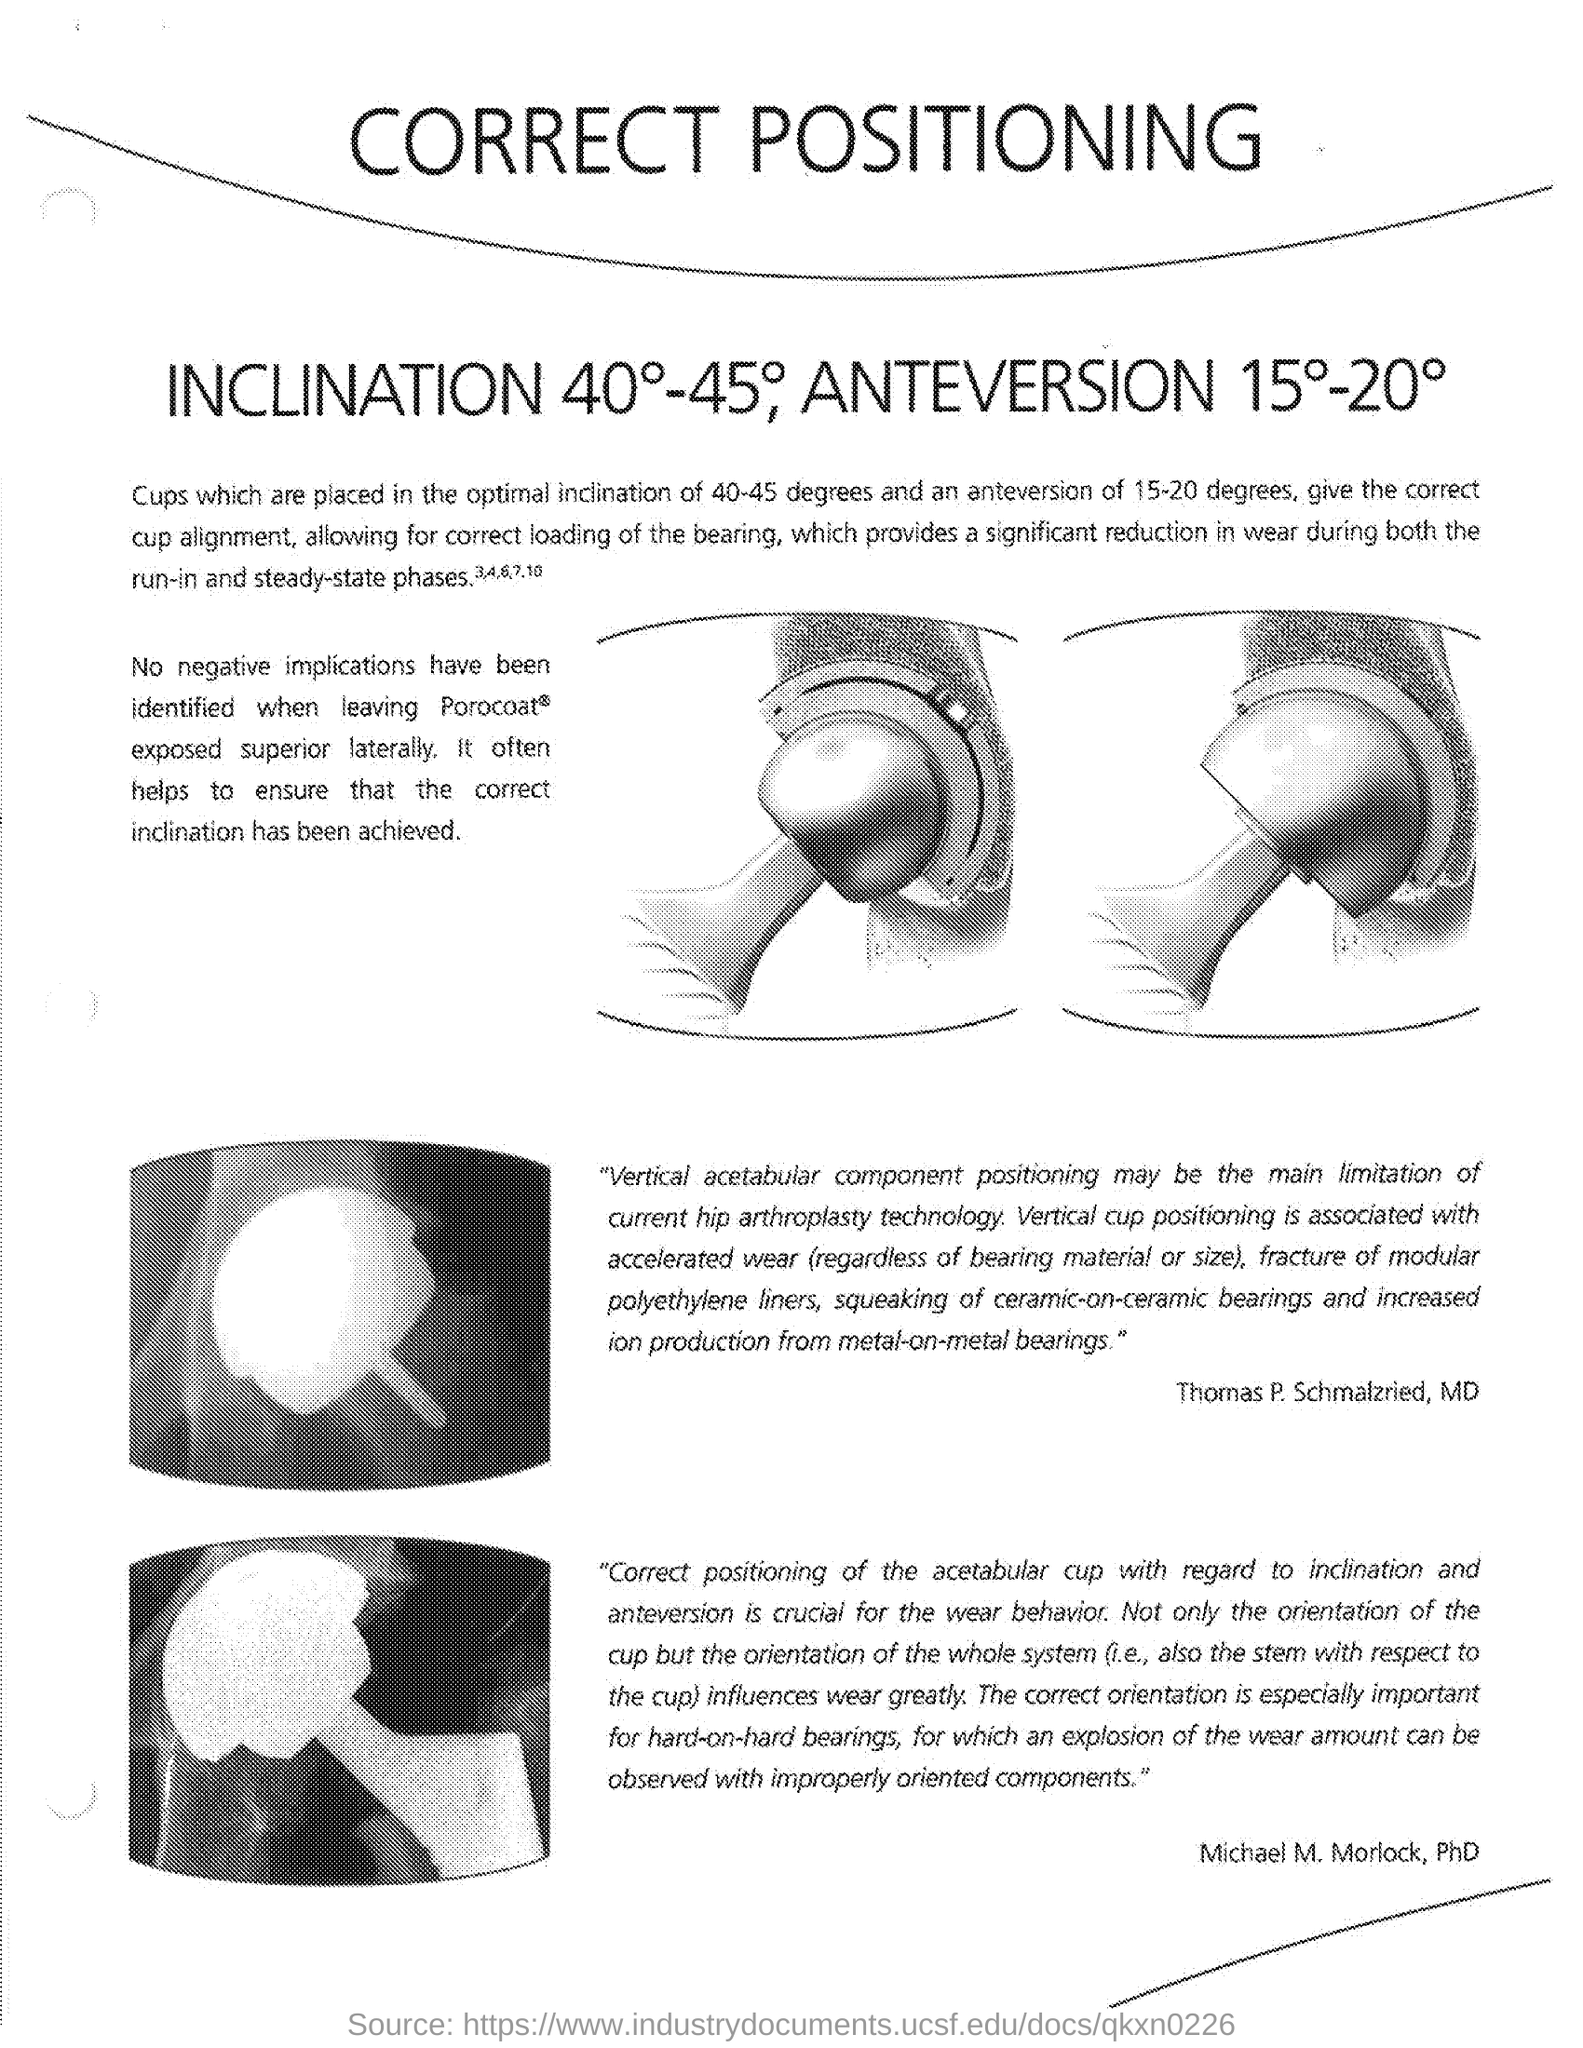Indicate a few pertinent items in this graphic. The title of the document is "What is the title of the document? Correct Positioning..". 